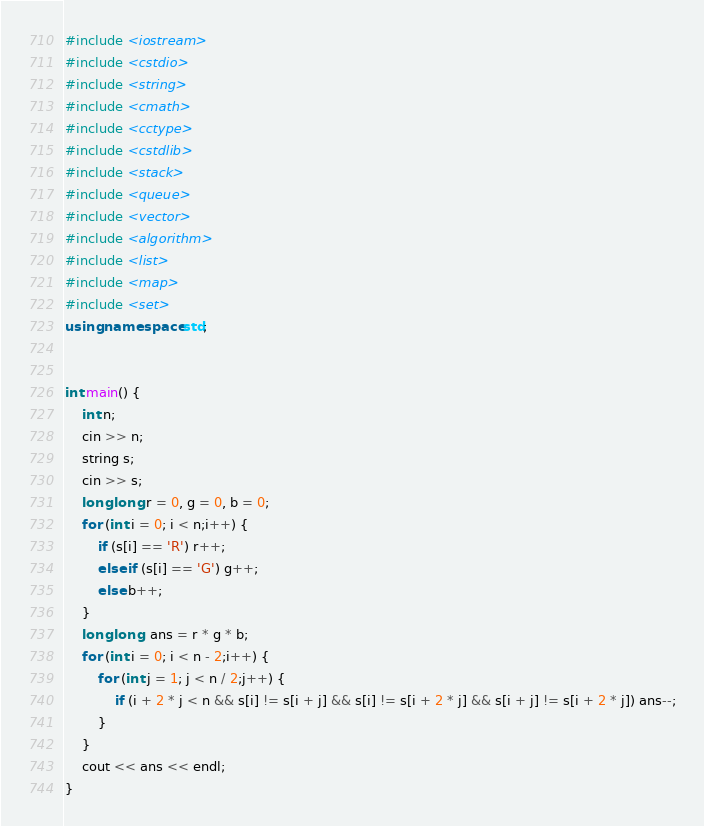<code> <loc_0><loc_0><loc_500><loc_500><_C++_>#include <iostream>
#include <cstdio>
#include <string>
#include <cmath>
#include <cctype>
#include <cstdlib>
#include <stack>
#include <queue>
#include <vector>
#include <algorithm>
#include <list>
#include <map>
#include <set>
using namespace std;


int main() {
	int n;
	cin >> n;
	string s;
	cin >> s;
	long long r = 0, g = 0, b = 0;
	for (int i = 0; i < n;i++) {
		if (s[i] == 'R') r++;
		else if (s[i] == 'G') g++;
		else b++;
	}
	long long  ans = r * g * b;
	for (int i = 0; i < n - 2;i++) {
		for (int j = 1; j < n / 2;j++) {
			if (i + 2 * j < n && s[i] != s[i + j] && s[i] != s[i + 2 * j] && s[i + j] != s[i + 2 * j]) ans--;
		}
	}
	cout << ans << endl;
}
</code> 